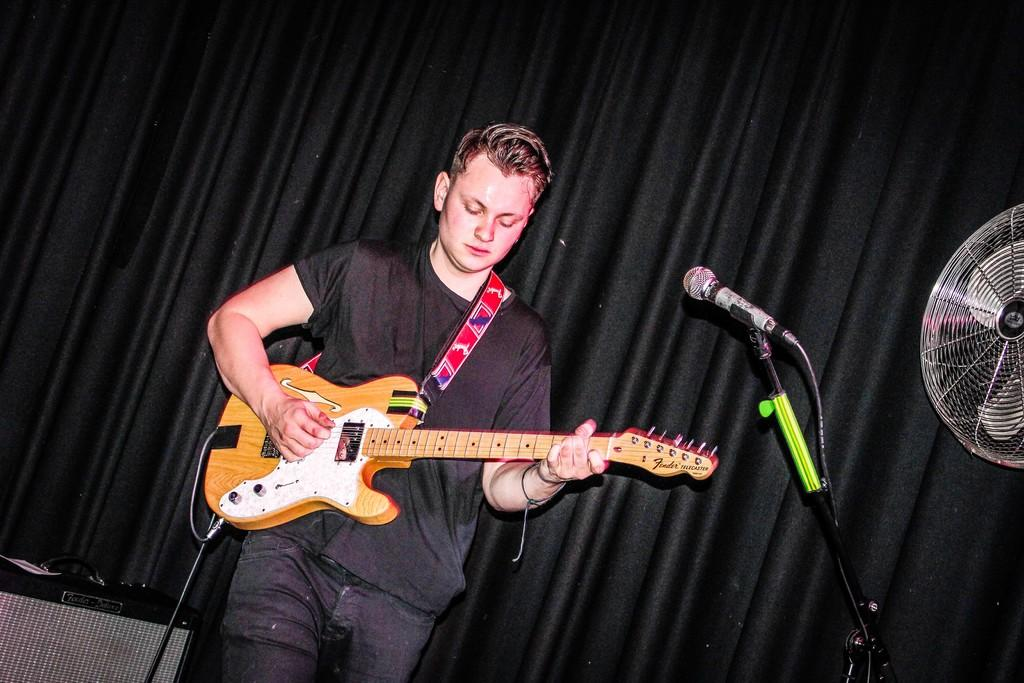What is the main subject of the image? The main subject of the image is a man. What is the man doing in the image? The man is standing and playing the guitar. What is the man wearing in the image? The man is wearing a black color T-Shirt. What can be seen behind the man in the image? There is a curtain behind the man. Can you see any airplanes taking off at the airport in the image? There is no airport or airplanes present in the image. What color are the man's eyes in the image? The color of the man's eyes cannot be determined from the image, as it only shows him from the waist up. 